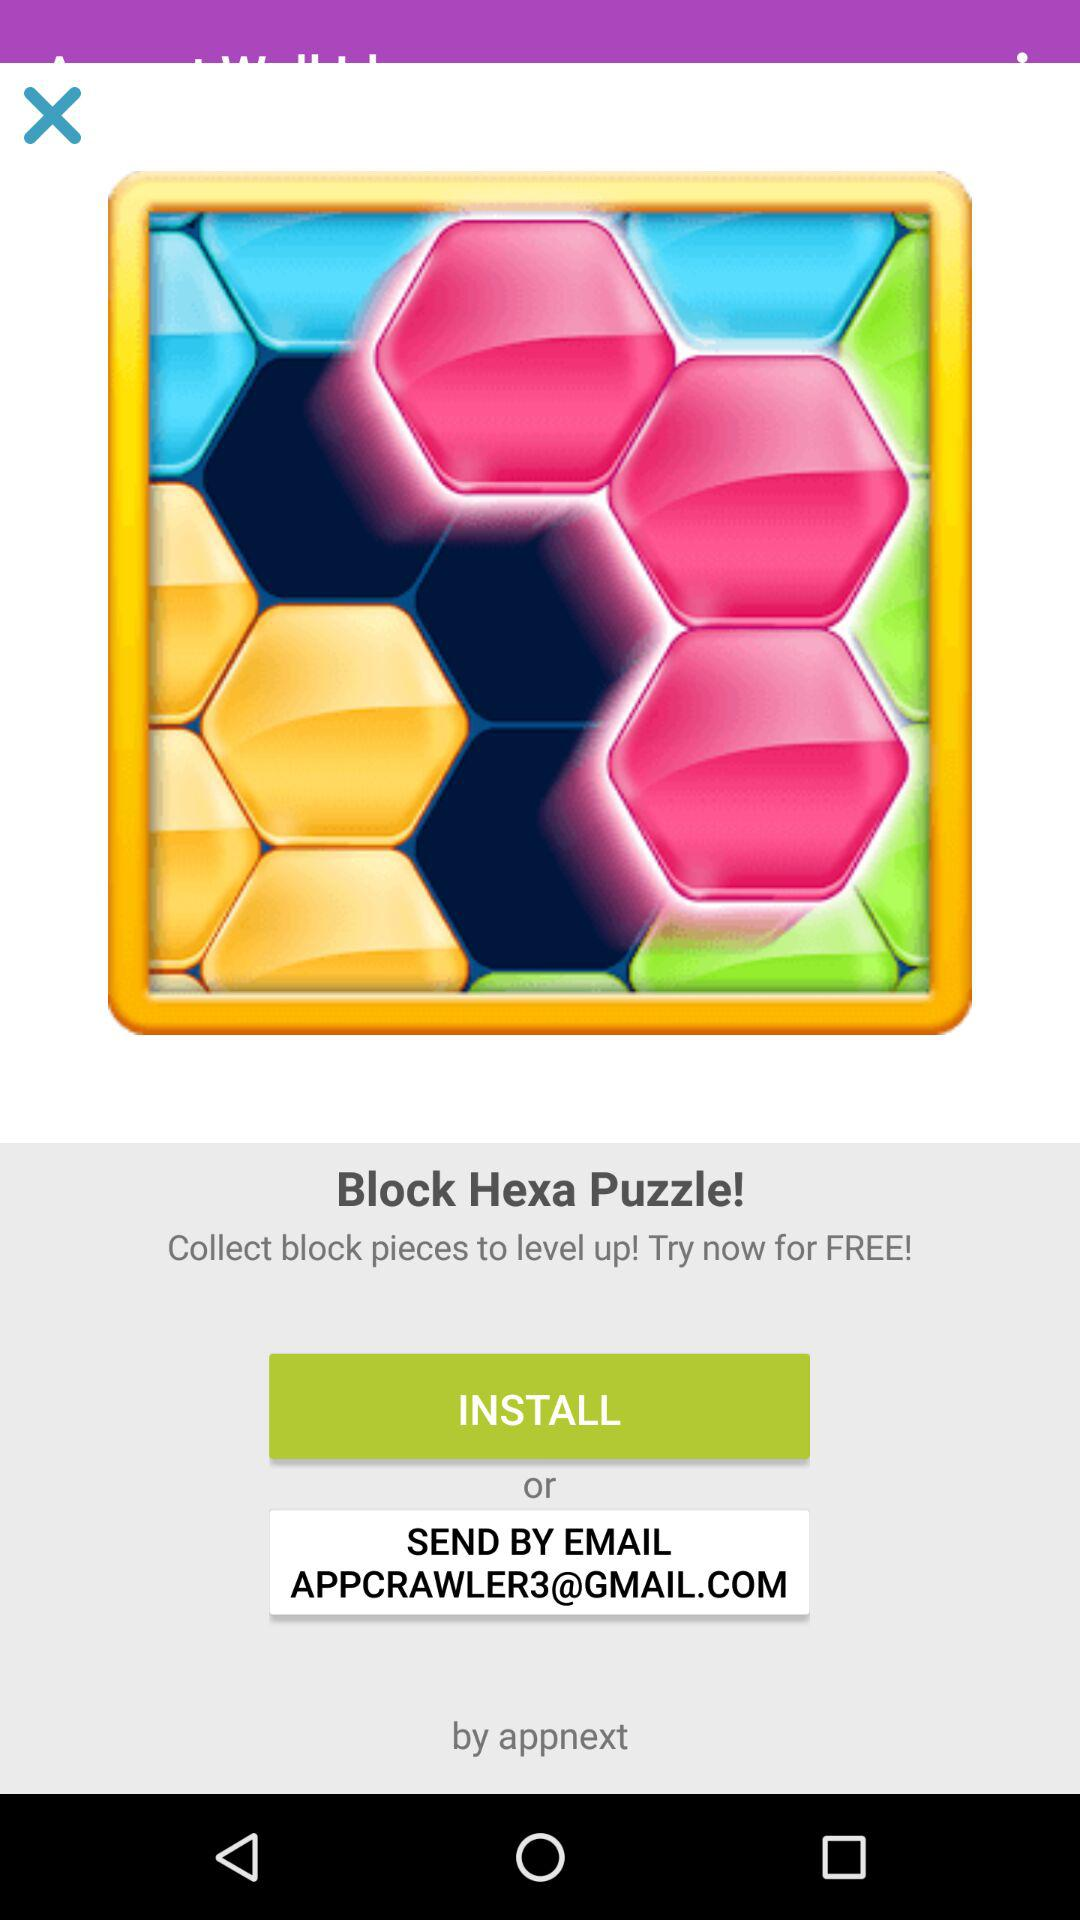Is the trial free or paid? The trial is free. 